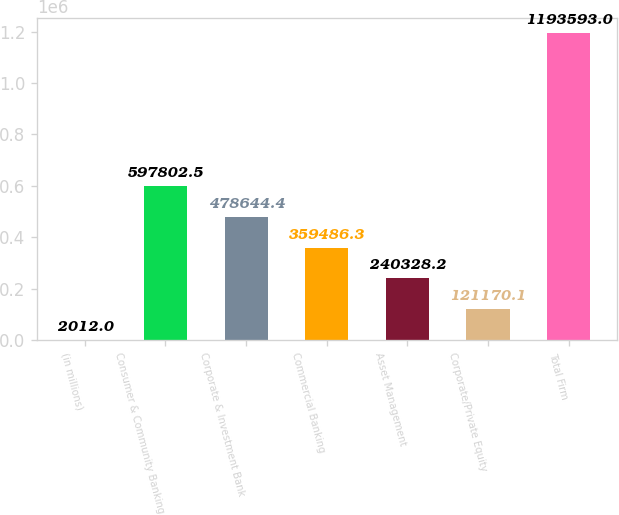Convert chart to OTSL. <chart><loc_0><loc_0><loc_500><loc_500><bar_chart><fcel>(in millions)<fcel>Consumer & Community Banking<fcel>Corporate & Investment Bank<fcel>Commercial Banking<fcel>Asset Management<fcel>Corporate/Private Equity<fcel>Total Firm<nl><fcel>2012<fcel>597802<fcel>478644<fcel>359486<fcel>240328<fcel>121170<fcel>1.19359e+06<nl></chart> 